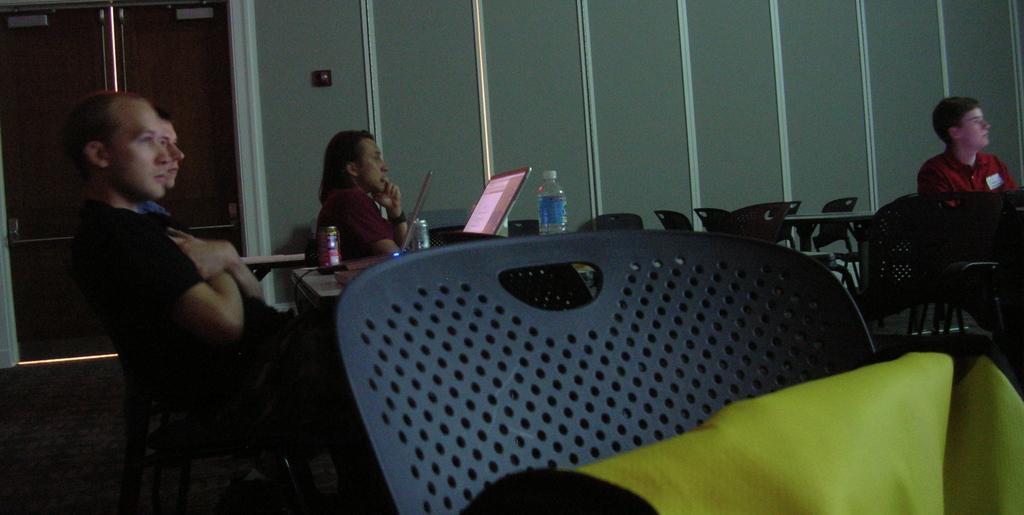Describe this image in one or two sentences. Four men are sitting at tables and listening to something. 